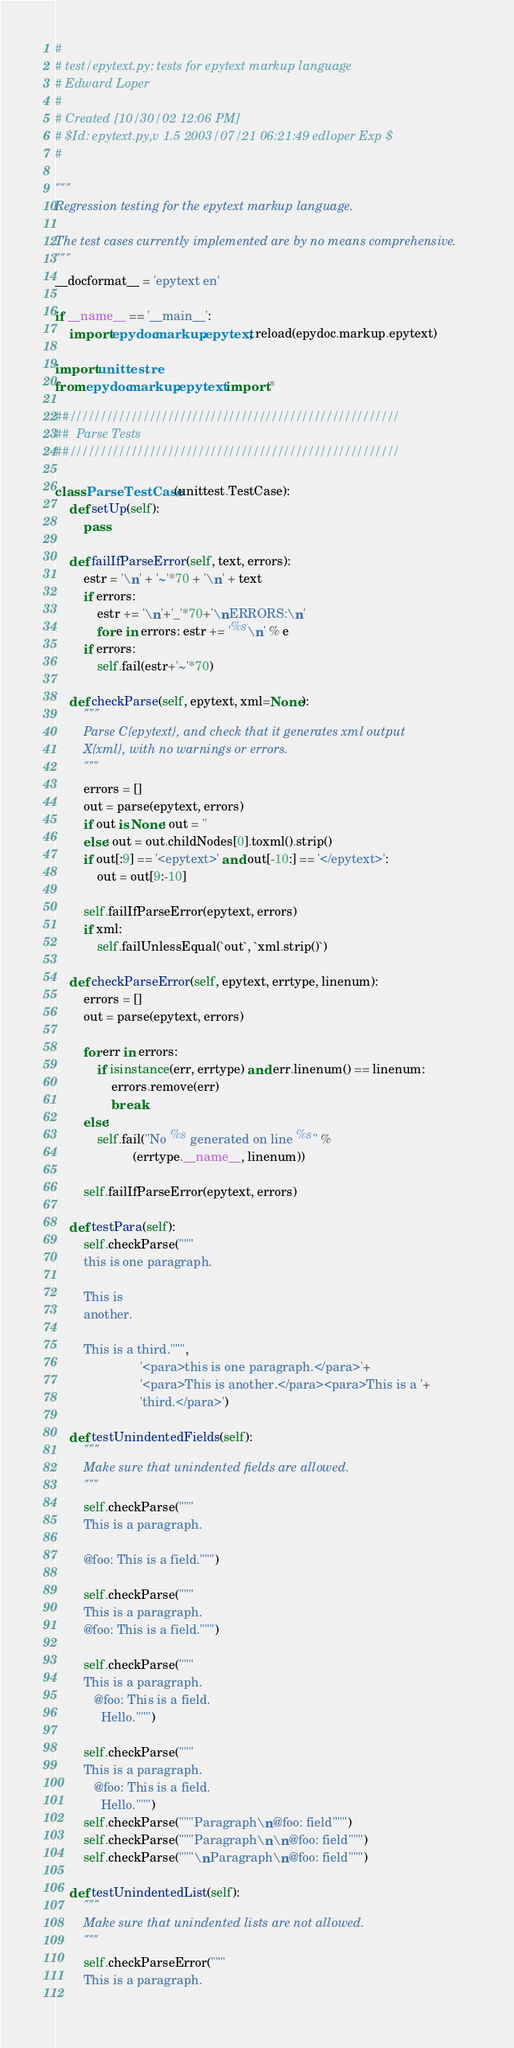Convert code to text. <code><loc_0><loc_0><loc_500><loc_500><_Python_>#
# test/epytext.py: tests for epytext markup language
# Edward Loper
#
# Created [10/30/02 12:06 PM]
# $Id: epytext.py,v 1.5 2003/07/21 06:21:49 edloper Exp $
#

"""
Regression testing for the epytext markup language.

The test cases currently implemented are by no means comprehensive.
"""
__docformat__ = 'epytext en'

if __name__ == '__main__':
    import epydoc.markup.epytext; reload(epydoc.markup.epytext)

import unittest, re
from epydoc.markup.epytext import *

##//////////////////////////////////////////////////////
##  Parse Tests
##//////////////////////////////////////////////////////

class ParseTestCase(unittest.TestCase):
    def setUp(self):
        pass

    def failIfParseError(self, text, errors):
        estr = '\n' + '~'*70 + '\n' + text
        if errors:
            estr += '\n'+'_'*70+'\nERRORS:\n'
            for e in errors: estr += '%s\n' % e
        if errors:
            self.fail(estr+'~'*70)

    def checkParse(self, epytext, xml=None):
        """
        Parse C{epytext}, and check that it generates xml output
        X{xml}, with no warnings or errors.
        """
        errors = []
        out = parse(epytext, errors)
        if out is None: out = ''
        else: out = out.childNodes[0].toxml().strip()
        if out[:9] == '<epytext>' and out[-10:] == '</epytext>':
            out = out[9:-10]
            
        self.failIfParseError(epytext, errors)
        if xml:
            self.failUnlessEqual(`out`, `xml.strip()`)

    def checkParseError(self, epytext, errtype, linenum):
        errors = []
        out = parse(epytext, errors)

        for err in errors:
            if isinstance(err, errtype) and err.linenum() == linenum:
                errors.remove(err)
                break
        else:
            self.fail("No %s generated on line %s" %
                      (errtype.__name__, linenum))

        self.failIfParseError(epytext, errors)

    def testPara(self):
        self.checkParse("""
        this is one paragraph.

        This is
        another.

        This is a third.""",
                        '<para>this is one paragraph.</para>'+
                        '<para>This is another.</para><para>This is a '+
                        'third.</para>')

    def testUnindentedFields(self):
        """
        Make sure that unindented fields are allowed.
        """
        self.checkParse("""
        This is a paragraph.
        
        @foo: This is a field.""")
        
        self.checkParse("""
        This is a paragraph.
        @foo: This is a field.""")
        
        self.checkParse("""
        This is a paragraph.
           @foo: This is a field.
             Hello.""")
        
        self.checkParse("""
        This is a paragraph.
           @foo: This is a field.
             Hello.""")
        self.checkParse("""Paragraph\n@foo: field""")
        self.checkParse("""Paragraph\n\n@foo: field""")
        self.checkParse("""\nParagraph\n@foo: field""")

    def testUnindentedList(self):
        """
        Make sure that unindented lists are not allowed.
        """
        self.checkParseError("""
        This is a paragraph.
        </code> 